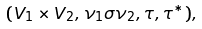<formula> <loc_0><loc_0><loc_500><loc_500>( V _ { 1 } \times V _ { 2 } , \nu _ { 1 } \sigma \nu _ { 2 } , \tau , \tau ^ { * } ) ,</formula> 